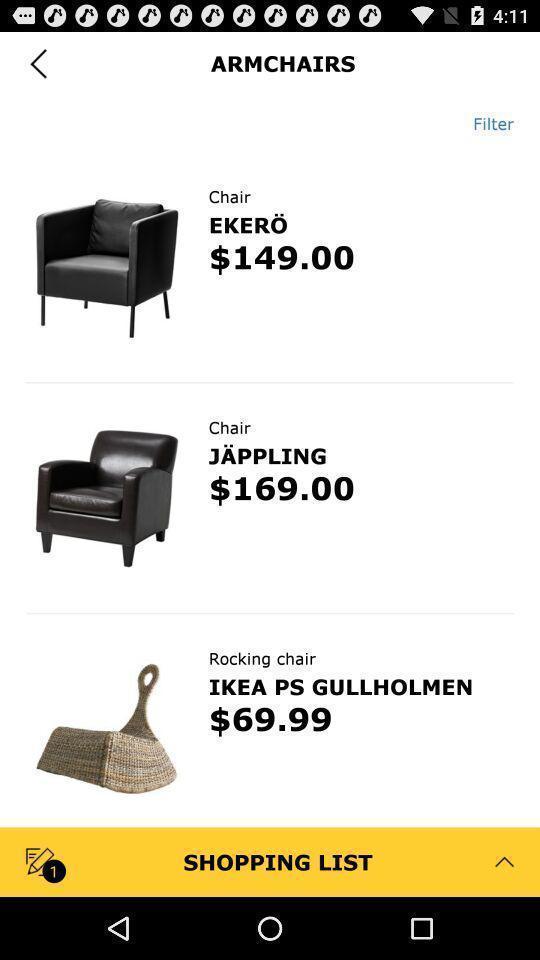What details can you identify in this image? Screen showing chair. 